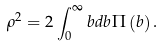Convert formula to latex. <formula><loc_0><loc_0><loc_500><loc_500>\rho ^ { 2 } = 2 \int _ { 0 } ^ { \infty } { b d b } \Pi \left ( b \right ) .</formula> 